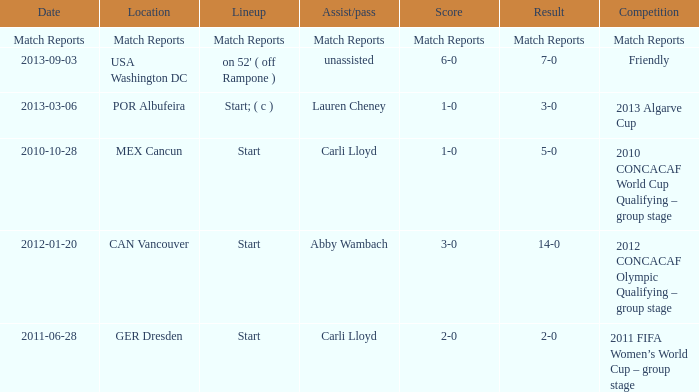Name the Lineup that has an Assist/pass of carli lloyd,a Competition of 2010 concacaf world cup qualifying – group stage? Start. 